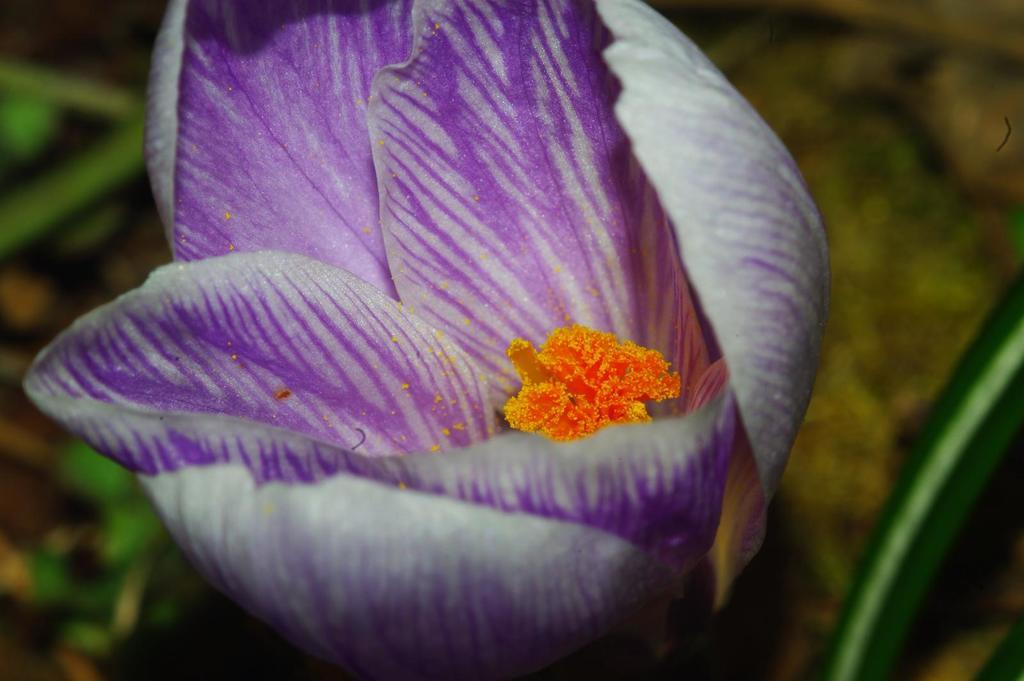What type of plant is featured in the image? There is a colorful flower in the image. What can be seen in the background of the image? There are trees in the background of the image. What type of light can be seen reflecting off the flower in the image? There is no specific mention of light reflecting off the flower in the image. 